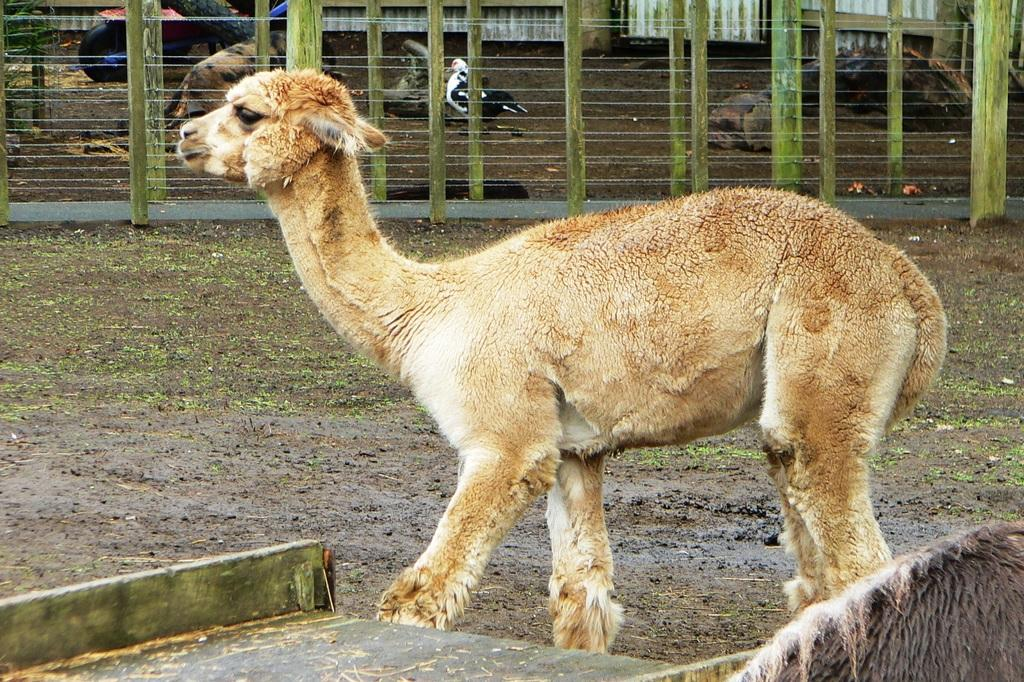What types of living organisms can be seen in the image? There are animals in the image, including a bird. What is the purpose of the fence in the image? The purpose of the fence in the image is not specified, but it could be for containing or separating the animals. What material is the wooden board at the bottom of the image made of? The wooden board at the bottom of the image is made of wood. Is there a stream of light visible in the image? There is no stream of light present in the image. 